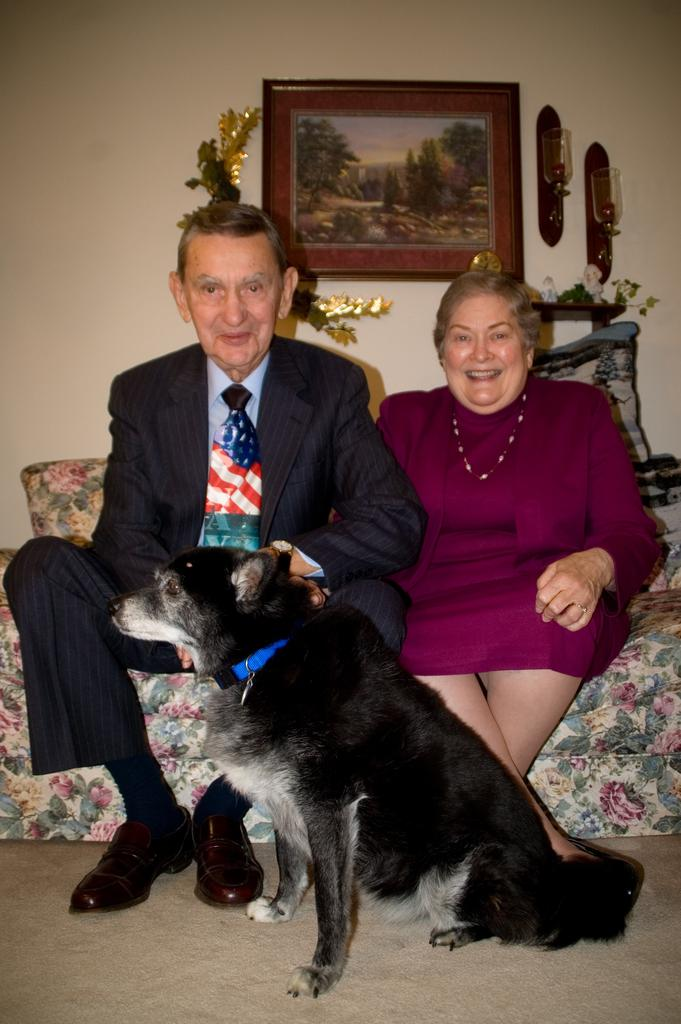What type of animal is in the image? There is a black colored dog in the image. Where is the dog located in the image? The dog is sitting on the floor. What are the two people doing in the image? The two people are sitting on a floral sofa in the image. What can be seen in the background of the image? There is a wall in the background of the image. What is hung on the wall in the image? A photo frame is hung on the wall. What degree does the porter have in the image? There is no porter present in the image, so it is not possible to determine their degree. 